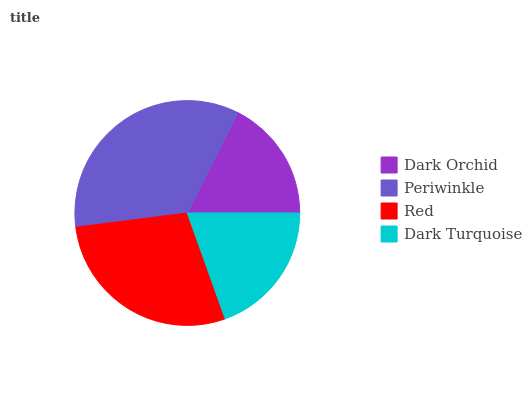Is Dark Orchid the minimum?
Answer yes or no. Yes. Is Periwinkle the maximum?
Answer yes or no. Yes. Is Red the minimum?
Answer yes or no. No. Is Red the maximum?
Answer yes or no. No. Is Periwinkle greater than Red?
Answer yes or no. Yes. Is Red less than Periwinkle?
Answer yes or no. Yes. Is Red greater than Periwinkle?
Answer yes or no. No. Is Periwinkle less than Red?
Answer yes or no. No. Is Red the high median?
Answer yes or no. Yes. Is Dark Turquoise the low median?
Answer yes or no. Yes. Is Dark Orchid the high median?
Answer yes or no. No. Is Red the low median?
Answer yes or no. No. 